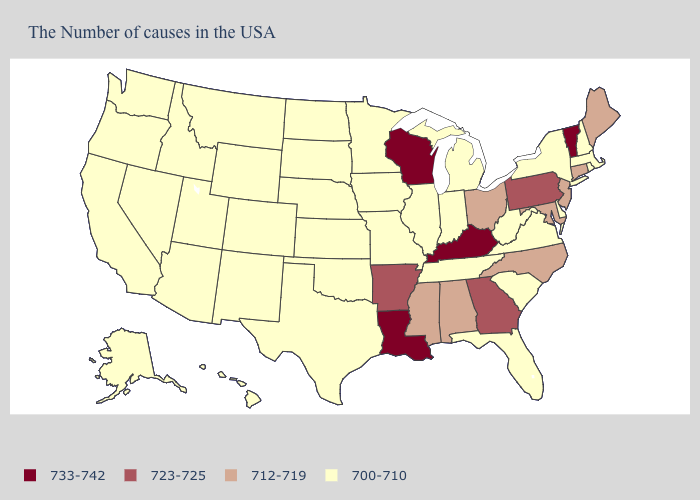Name the states that have a value in the range 700-710?
Quick response, please. Massachusetts, Rhode Island, New Hampshire, New York, Delaware, Virginia, South Carolina, West Virginia, Florida, Michigan, Indiana, Tennessee, Illinois, Missouri, Minnesota, Iowa, Kansas, Nebraska, Oklahoma, Texas, South Dakota, North Dakota, Wyoming, Colorado, New Mexico, Utah, Montana, Arizona, Idaho, Nevada, California, Washington, Oregon, Alaska, Hawaii. Name the states that have a value in the range 700-710?
Short answer required. Massachusetts, Rhode Island, New Hampshire, New York, Delaware, Virginia, South Carolina, West Virginia, Florida, Michigan, Indiana, Tennessee, Illinois, Missouri, Minnesota, Iowa, Kansas, Nebraska, Oklahoma, Texas, South Dakota, North Dakota, Wyoming, Colorado, New Mexico, Utah, Montana, Arizona, Idaho, Nevada, California, Washington, Oregon, Alaska, Hawaii. What is the value of Virginia?
Be succinct. 700-710. What is the value of Maryland?
Answer briefly. 712-719. Among the states that border Wyoming , which have the lowest value?
Give a very brief answer. Nebraska, South Dakota, Colorado, Utah, Montana, Idaho. Name the states that have a value in the range 712-719?
Answer briefly. Maine, Connecticut, New Jersey, Maryland, North Carolina, Ohio, Alabama, Mississippi. How many symbols are there in the legend?
Quick response, please. 4. Among the states that border Virginia , which have the lowest value?
Write a very short answer. West Virginia, Tennessee. Name the states that have a value in the range 712-719?
Concise answer only. Maine, Connecticut, New Jersey, Maryland, North Carolina, Ohio, Alabama, Mississippi. Which states have the highest value in the USA?
Keep it brief. Vermont, Kentucky, Wisconsin, Louisiana. Name the states that have a value in the range 712-719?
Quick response, please. Maine, Connecticut, New Jersey, Maryland, North Carolina, Ohio, Alabama, Mississippi. Name the states that have a value in the range 712-719?
Keep it brief. Maine, Connecticut, New Jersey, Maryland, North Carolina, Ohio, Alabama, Mississippi. What is the value of Connecticut?
Short answer required. 712-719. Among the states that border Kentucky , which have the lowest value?
Concise answer only. Virginia, West Virginia, Indiana, Tennessee, Illinois, Missouri. 